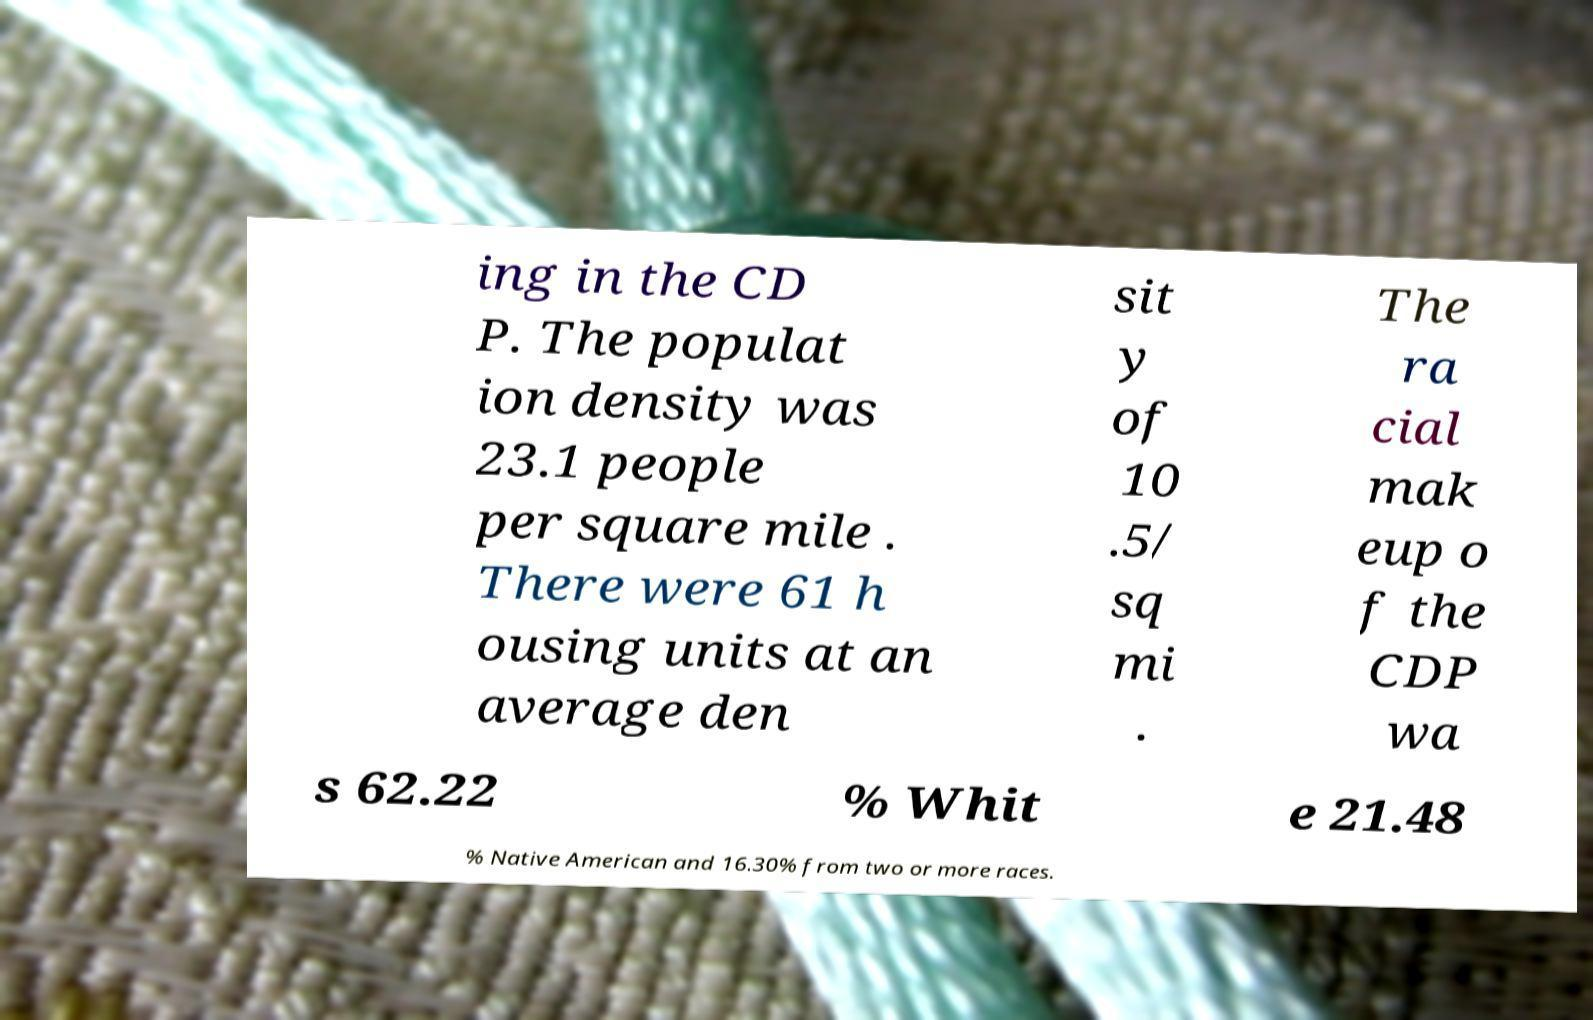I need the written content from this picture converted into text. Can you do that? ing in the CD P. The populat ion density was 23.1 people per square mile . There were 61 h ousing units at an average den sit y of 10 .5/ sq mi . The ra cial mak eup o f the CDP wa s 62.22 % Whit e 21.48 % Native American and 16.30% from two or more races. 